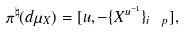Convert formula to latex. <formula><loc_0><loc_0><loc_500><loc_500>\pi ^ { \natural } ( d \mu _ { X } ) = [ u , - \{ X ^ { u ^ { - 1 } } \} _ { i \ p } ] ,</formula> 